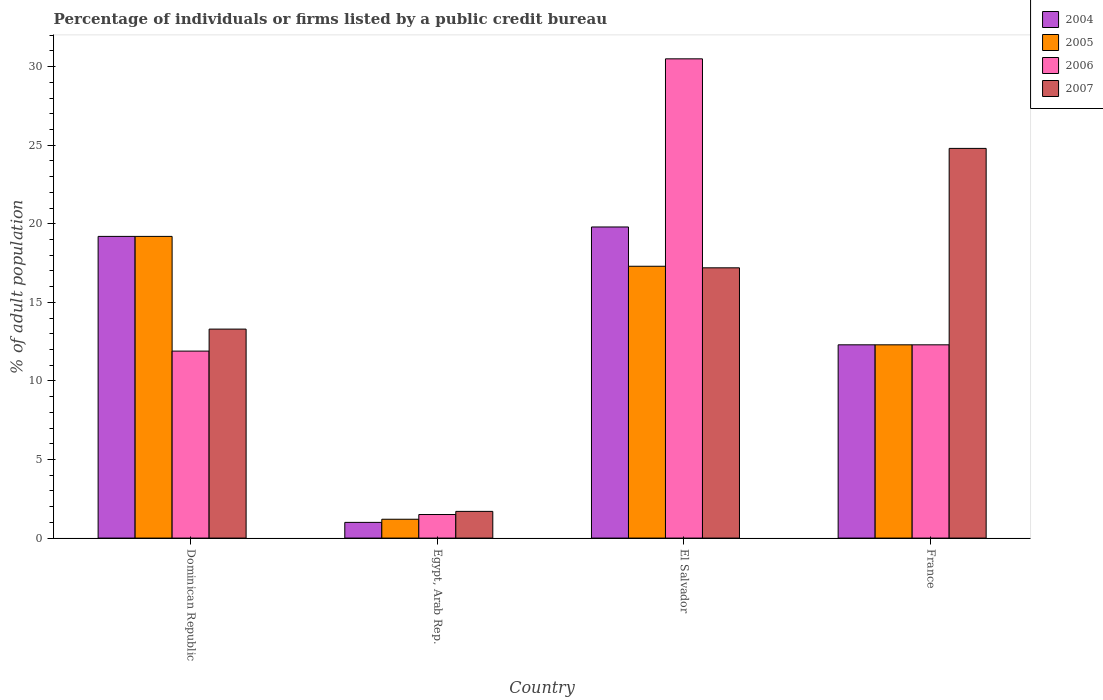How many different coloured bars are there?
Provide a succinct answer. 4. How many groups of bars are there?
Your response must be concise. 4. Are the number of bars per tick equal to the number of legend labels?
Ensure brevity in your answer.  Yes. Are the number of bars on each tick of the X-axis equal?
Offer a terse response. Yes. How many bars are there on the 4th tick from the left?
Your response must be concise. 4. How many bars are there on the 4th tick from the right?
Provide a succinct answer. 4. What is the label of the 2nd group of bars from the left?
Ensure brevity in your answer.  Egypt, Arab Rep. In how many cases, is the number of bars for a given country not equal to the number of legend labels?
Your answer should be compact. 0. Across all countries, what is the maximum percentage of population listed by a public credit bureau in 2006?
Make the answer very short. 30.5. Across all countries, what is the minimum percentage of population listed by a public credit bureau in 2004?
Keep it short and to the point. 1. In which country was the percentage of population listed by a public credit bureau in 2007 maximum?
Keep it short and to the point. France. In which country was the percentage of population listed by a public credit bureau in 2006 minimum?
Your response must be concise. Egypt, Arab Rep. What is the total percentage of population listed by a public credit bureau in 2006 in the graph?
Offer a very short reply. 56.2. What is the difference between the percentage of population listed by a public credit bureau in 2004 in Egypt, Arab Rep. and that in France?
Provide a succinct answer. -11.3. What is the difference between the percentage of population listed by a public credit bureau in 2004 in France and the percentage of population listed by a public credit bureau in 2006 in Egypt, Arab Rep.?
Your response must be concise. 10.8. What is the difference between the percentage of population listed by a public credit bureau of/in 2007 and percentage of population listed by a public credit bureau of/in 2004 in El Salvador?
Your answer should be very brief. -2.6. In how many countries, is the percentage of population listed by a public credit bureau in 2004 greater than 1 %?
Offer a terse response. 3. What is the ratio of the percentage of population listed by a public credit bureau in 2005 in Egypt, Arab Rep. to that in France?
Make the answer very short. 0.1. Is the difference between the percentage of population listed by a public credit bureau in 2007 in Dominican Republic and El Salvador greater than the difference between the percentage of population listed by a public credit bureau in 2004 in Dominican Republic and El Salvador?
Your answer should be compact. No. What is the difference between the highest and the second highest percentage of population listed by a public credit bureau in 2005?
Keep it short and to the point. -1.9. What is the difference between the highest and the lowest percentage of population listed by a public credit bureau in 2007?
Provide a short and direct response. 23.1. What does the 3rd bar from the left in France represents?
Provide a short and direct response. 2006. What does the 3rd bar from the right in El Salvador represents?
Ensure brevity in your answer.  2005. Does the graph contain any zero values?
Provide a short and direct response. No. Where does the legend appear in the graph?
Provide a succinct answer. Top right. How many legend labels are there?
Make the answer very short. 4. What is the title of the graph?
Make the answer very short. Percentage of individuals or firms listed by a public credit bureau. Does "1985" appear as one of the legend labels in the graph?
Make the answer very short. No. What is the label or title of the X-axis?
Your response must be concise. Country. What is the label or title of the Y-axis?
Give a very brief answer. % of adult population. What is the % of adult population in 2004 in Dominican Republic?
Provide a short and direct response. 19.2. What is the % of adult population of 2006 in Dominican Republic?
Offer a terse response. 11.9. What is the % of adult population in 2007 in Dominican Republic?
Offer a terse response. 13.3. What is the % of adult population in 2004 in Egypt, Arab Rep.?
Offer a terse response. 1. What is the % of adult population of 2005 in Egypt, Arab Rep.?
Provide a short and direct response. 1.2. What is the % of adult population of 2006 in Egypt, Arab Rep.?
Offer a very short reply. 1.5. What is the % of adult population in 2007 in Egypt, Arab Rep.?
Provide a short and direct response. 1.7. What is the % of adult population in 2004 in El Salvador?
Keep it short and to the point. 19.8. What is the % of adult population in 2005 in El Salvador?
Offer a very short reply. 17.3. What is the % of adult population of 2006 in El Salvador?
Offer a terse response. 30.5. What is the % of adult population in 2007 in El Salvador?
Provide a short and direct response. 17.2. What is the % of adult population of 2004 in France?
Provide a succinct answer. 12.3. What is the % of adult population in 2005 in France?
Ensure brevity in your answer.  12.3. What is the % of adult population in 2007 in France?
Offer a very short reply. 24.8. Across all countries, what is the maximum % of adult population of 2004?
Give a very brief answer. 19.8. Across all countries, what is the maximum % of adult population in 2005?
Offer a terse response. 19.2. Across all countries, what is the maximum % of adult population of 2006?
Give a very brief answer. 30.5. Across all countries, what is the maximum % of adult population of 2007?
Ensure brevity in your answer.  24.8. Across all countries, what is the minimum % of adult population in 2005?
Your answer should be very brief. 1.2. What is the total % of adult population of 2004 in the graph?
Your answer should be compact. 52.3. What is the total % of adult population in 2006 in the graph?
Your response must be concise. 56.2. What is the total % of adult population in 2007 in the graph?
Offer a very short reply. 57. What is the difference between the % of adult population of 2007 in Dominican Republic and that in Egypt, Arab Rep.?
Your answer should be very brief. 11.6. What is the difference between the % of adult population in 2005 in Dominican Republic and that in El Salvador?
Make the answer very short. 1.9. What is the difference between the % of adult population in 2006 in Dominican Republic and that in El Salvador?
Ensure brevity in your answer.  -18.6. What is the difference between the % of adult population of 2007 in Dominican Republic and that in El Salvador?
Offer a terse response. -3.9. What is the difference between the % of adult population of 2007 in Dominican Republic and that in France?
Give a very brief answer. -11.5. What is the difference between the % of adult population in 2004 in Egypt, Arab Rep. and that in El Salvador?
Provide a short and direct response. -18.8. What is the difference between the % of adult population of 2005 in Egypt, Arab Rep. and that in El Salvador?
Provide a short and direct response. -16.1. What is the difference between the % of adult population in 2006 in Egypt, Arab Rep. and that in El Salvador?
Keep it short and to the point. -29. What is the difference between the % of adult population in 2007 in Egypt, Arab Rep. and that in El Salvador?
Your response must be concise. -15.5. What is the difference between the % of adult population of 2007 in Egypt, Arab Rep. and that in France?
Provide a succinct answer. -23.1. What is the difference between the % of adult population in 2004 in El Salvador and that in France?
Offer a terse response. 7.5. What is the difference between the % of adult population of 2005 in El Salvador and that in France?
Offer a very short reply. 5. What is the difference between the % of adult population in 2004 in Dominican Republic and the % of adult population in 2005 in Egypt, Arab Rep.?
Offer a very short reply. 18. What is the difference between the % of adult population in 2004 in Dominican Republic and the % of adult population in 2006 in Egypt, Arab Rep.?
Keep it short and to the point. 17.7. What is the difference between the % of adult population of 2005 in Dominican Republic and the % of adult population of 2007 in Egypt, Arab Rep.?
Your answer should be compact. 17.5. What is the difference between the % of adult population in 2005 in Dominican Republic and the % of adult population in 2006 in El Salvador?
Make the answer very short. -11.3. What is the difference between the % of adult population in 2006 in Dominican Republic and the % of adult population in 2007 in El Salvador?
Ensure brevity in your answer.  -5.3. What is the difference between the % of adult population of 2004 in Dominican Republic and the % of adult population of 2005 in France?
Your answer should be very brief. 6.9. What is the difference between the % of adult population in 2004 in Dominican Republic and the % of adult population in 2006 in France?
Provide a short and direct response. 6.9. What is the difference between the % of adult population in 2004 in Dominican Republic and the % of adult population in 2007 in France?
Offer a terse response. -5.6. What is the difference between the % of adult population in 2005 in Dominican Republic and the % of adult population in 2007 in France?
Your answer should be very brief. -5.6. What is the difference between the % of adult population of 2004 in Egypt, Arab Rep. and the % of adult population of 2005 in El Salvador?
Provide a short and direct response. -16.3. What is the difference between the % of adult population in 2004 in Egypt, Arab Rep. and the % of adult population in 2006 in El Salvador?
Offer a very short reply. -29.5. What is the difference between the % of adult population in 2004 in Egypt, Arab Rep. and the % of adult population in 2007 in El Salvador?
Ensure brevity in your answer.  -16.2. What is the difference between the % of adult population of 2005 in Egypt, Arab Rep. and the % of adult population of 2006 in El Salvador?
Keep it short and to the point. -29.3. What is the difference between the % of adult population of 2005 in Egypt, Arab Rep. and the % of adult population of 2007 in El Salvador?
Provide a succinct answer. -16. What is the difference between the % of adult population in 2006 in Egypt, Arab Rep. and the % of adult population in 2007 in El Salvador?
Your answer should be compact. -15.7. What is the difference between the % of adult population of 2004 in Egypt, Arab Rep. and the % of adult population of 2005 in France?
Keep it short and to the point. -11.3. What is the difference between the % of adult population in 2004 in Egypt, Arab Rep. and the % of adult population in 2006 in France?
Provide a short and direct response. -11.3. What is the difference between the % of adult population in 2004 in Egypt, Arab Rep. and the % of adult population in 2007 in France?
Make the answer very short. -23.8. What is the difference between the % of adult population of 2005 in Egypt, Arab Rep. and the % of adult population of 2006 in France?
Provide a succinct answer. -11.1. What is the difference between the % of adult population in 2005 in Egypt, Arab Rep. and the % of adult population in 2007 in France?
Offer a very short reply. -23.6. What is the difference between the % of adult population of 2006 in Egypt, Arab Rep. and the % of adult population of 2007 in France?
Give a very brief answer. -23.3. What is the difference between the % of adult population in 2004 in El Salvador and the % of adult population in 2006 in France?
Provide a succinct answer. 7.5. What is the difference between the % of adult population in 2005 in El Salvador and the % of adult population in 2006 in France?
Offer a very short reply. 5. What is the difference between the % of adult population in 2006 in El Salvador and the % of adult population in 2007 in France?
Offer a terse response. 5.7. What is the average % of adult population in 2004 per country?
Offer a terse response. 13.07. What is the average % of adult population of 2006 per country?
Offer a terse response. 14.05. What is the average % of adult population of 2007 per country?
Offer a terse response. 14.25. What is the difference between the % of adult population in 2004 and % of adult population in 2006 in Dominican Republic?
Your answer should be compact. 7.3. What is the difference between the % of adult population of 2004 and % of adult population of 2005 in Egypt, Arab Rep.?
Offer a very short reply. -0.2. What is the difference between the % of adult population in 2004 and % of adult population in 2006 in Egypt, Arab Rep.?
Offer a very short reply. -0.5. What is the difference between the % of adult population of 2005 and % of adult population of 2007 in Egypt, Arab Rep.?
Make the answer very short. -0.5. What is the difference between the % of adult population of 2006 and % of adult population of 2007 in Egypt, Arab Rep.?
Your answer should be very brief. -0.2. What is the difference between the % of adult population in 2004 and % of adult population in 2005 in El Salvador?
Provide a succinct answer. 2.5. What is the difference between the % of adult population in 2004 and % of adult population in 2007 in El Salvador?
Offer a very short reply. 2.6. What is the difference between the % of adult population of 2006 and % of adult population of 2007 in El Salvador?
Provide a succinct answer. 13.3. What is the difference between the % of adult population of 2004 and % of adult population of 2006 in France?
Keep it short and to the point. 0. What is the ratio of the % of adult population of 2005 in Dominican Republic to that in Egypt, Arab Rep.?
Your answer should be very brief. 16. What is the ratio of the % of adult population of 2006 in Dominican Republic to that in Egypt, Arab Rep.?
Keep it short and to the point. 7.93. What is the ratio of the % of adult population in 2007 in Dominican Republic to that in Egypt, Arab Rep.?
Provide a short and direct response. 7.82. What is the ratio of the % of adult population of 2004 in Dominican Republic to that in El Salvador?
Ensure brevity in your answer.  0.97. What is the ratio of the % of adult population in 2005 in Dominican Republic to that in El Salvador?
Give a very brief answer. 1.11. What is the ratio of the % of adult population in 2006 in Dominican Republic to that in El Salvador?
Your response must be concise. 0.39. What is the ratio of the % of adult population of 2007 in Dominican Republic to that in El Salvador?
Offer a terse response. 0.77. What is the ratio of the % of adult population of 2004 in Dominican Republic to that in France?
Keep it short and to the point. 1.56. What is the ratio of the % of adult population in 2005 in Dominican Republic to that in France?
Keep it short and to the point. 1.56. What is the ratio of the % of adult population of 2006 in Dominican Republic to that in France?
Provide a short and direct response. 0.97. What is the ratio of the % of adult population of 2007 in Dominican Republic to that in France?
Ensure brevity in your answer.  0.54. What is the ratio of the % of adult population in 2004 in Egypt, Arab Rep. to that in El Salvador?
Your answer should be compact. 0.05. What is the ratio of the % of adult population of 2005 in Egypt, Arab Rep. to that in El Salvador?
Give a very brief answer. 0.07. What is the ratio of the % of adult population in 2006 in Egypt, Arab Rep. to that in El Salvador?
Give a very brief answer. 0.05. What is the ratio of the % of adult population in 2007 in Egypt, Arab Rep. to that in El Salvador?
Offer a terse response. 0.1. What is the ratio of the % of adult population of 2004 in Egypt, Arab Rep. to that in France?
Give a very brief answer. 0.08. What is the ratio of the % of adult population of 2005 in Egypt, Arab Rep. to that in France?
Provide a short and direct response. 0.1. What is the ratio of the % of adult population of 2006 in Egypt, Arab Rep. to that in France?
Give a very brief answer. 0.12. What is the ratio of the % of adult population of 2007 in Egypt, Arab Rep. to that in France?
Your answer should be compact. 0.07. What is the ratio of the % of adult population in 2004 in El Salvador to that in France?
Ensure brevity in your answer.  1.61. What is the ratio of the % of adult population of 2005 in El Salvador to that in France?
Your response must be concise. 1.41. What is the ratio of the % of adult population of 2006 in El Salvador to that in France?
Ensure brevity in your answer.  2.48. What is the ratio of the % of adult population of 2007 in El Salvador to that in France?
Give a very brief answer. 0.69. What is the difference between the highest and the second highest % of adult population of 2004?
Your answer should be very brief. 0.6. What is the difference between the highest and the second highest % of adult population in 2005?
Keep it short and to the point. 1.9. What is the difference between the highest and the lowest % of adult population of 2005?
Make the answer very short. 18. What is the difference between the highest and the lowest % of adult population of 2006?
Your response must be concise. 29. What is the difference between the highest and the lowest % of adult population of 2007?
Make the answer very short. 23.1. 